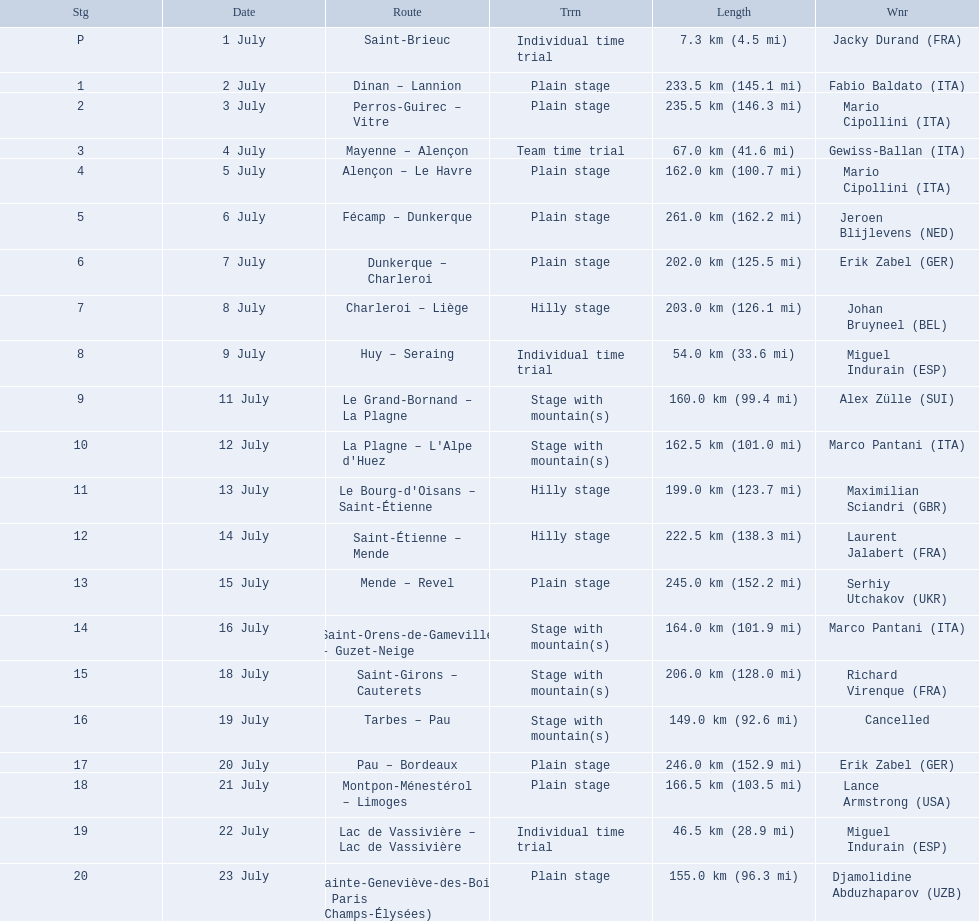What were the dates of the 1995 tour de france? 1 July, 2 July, 3 July, 4 July, 5 July, 6 July, 7 July, 8 July, 9 July, 11 July, 12 July, 13 July, 14 July, 15 July, 16 July, 18 July, 19 July, 20 July, 21 July, 22 July, 23 July. What was the length for july 8th? 203.0 km (126.1 mi). 